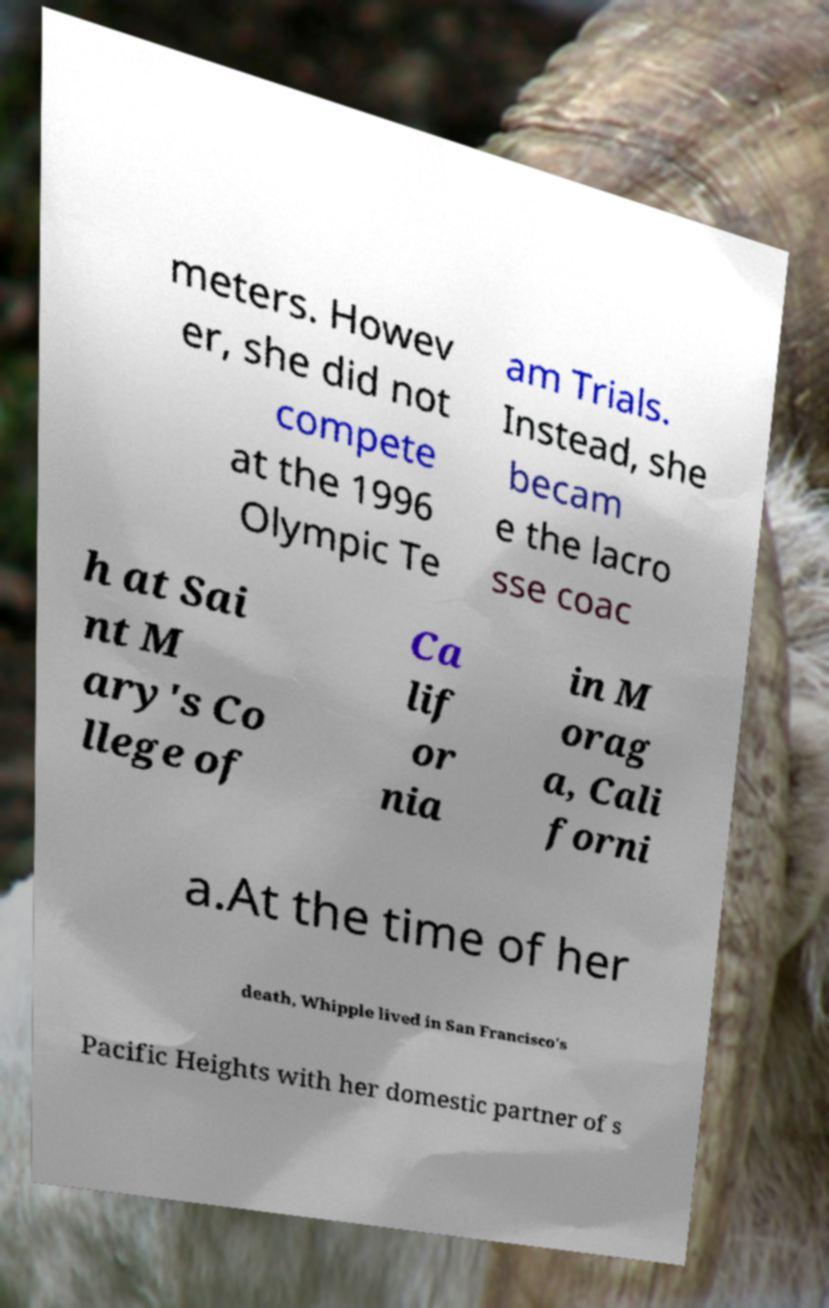What messages or text are displayed in this image? I need them in a readable, typed format. meters. Howev er, she did not compete at the 1996 Olympic Te am Trials. Instead, she becam e the lacro sse coac h at Sai nt M ary's Co llege of Ca lif or nia in M orag a, Cali forni a.At the time of her death, Whipple lived in San Francisco's Pacific Heights with her domestic partner of s 